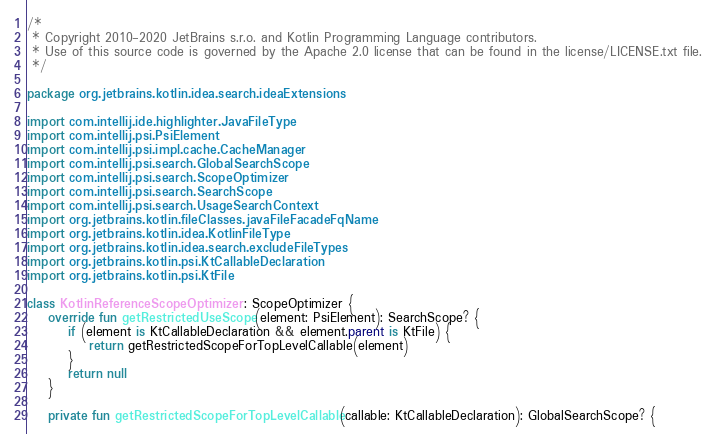<code> <loc_0><loc_0><loc_500><loc_500><_Kotlin_>/*
 * Copyright 2010-2020 JetBrains s.r.o. and Kotlin Programming Language contributors.
 * Use of this source code is governed by the Apache 2.0 license that can be found in the license/LICENSE.txt file.
 */

package org.jetbrains.kotlin.idea.search.ideaExtensions

import com.intellij.ide.highlighter.JavaFileType
import com.intellij.psi.PsiElement
import com.intellij.psi.impl.cache.CacheManager
import com.intellij.psi.search.GlobalSearchScope
import com.intellij.psi.search.ScopeOptimizer
import com.intellij.psi.search.SearchScope
import com.intellij.psi.search.UsageSearchContext
import org.jetbrains.kotlin.fileClasses.javaFileFacadeFqName
import org.jetbrains.kotlin.idea.KotlinFileType
import org.jetbrains.kotlin.idea.search.excludeFileTypes
import org.jetbrains.kotlin.psi.KtCallableDeclaration
import org.jetbrains.kotlin.psi.KtFile

class KotlinReferenceScopeOptimizer : ScopeOptimizer {
    override fun getRestrictedUseScope(element: PsiElement): SearchScope? {
        if (element is KtCallableDeclaration && element.parent is KtFile) {
            return getRestrictedScopeForTopLevelCallable(element)
        }
        return null
    }

    private fun getRestrictedScopeForTopLevelCallable(callable: KtCallableDeclaration): GlobalSearchScope? {</code> 